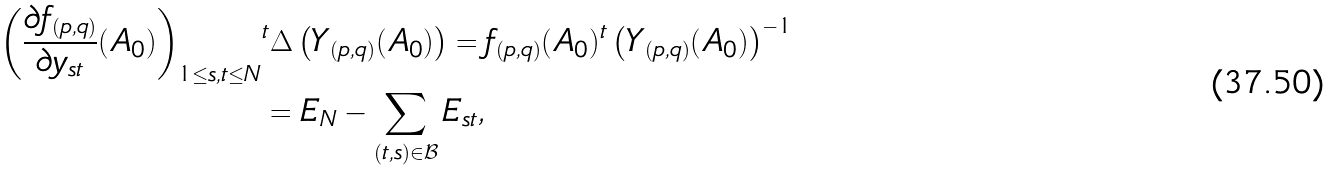Convert formula to latex. <formula><loc_0><loc_0><loc_500><loc_500>\left ( \frac { \partial f _ { ( p , q ) } } { \partial y _ { s t } } ( A _ { 0 } ) \right ) _ { 1 \leq s , t \leq N } & ^ { t } \Delta \left ( Y _ { ( p , q ) } ( A _ { 0 } ) \right ) = f _ { ( p , q ) } ( A _ { 0 } ) ^ { t } \left ( Y _ { ( p , q ) } ( A _ { 0 } ) \right ) ^ { - 1 } \\ & = E _ { N } - \sum _ { ( t , s ) \in \mathcal { B } } E _ { s t } ,</formula> 